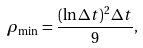<formula> <loc_0><loc_0><loc_500><loc_500>\rho _ { \min } = \frac { ( \ln \Delta t ) ^ { 2 } \Delta t } { 9 } ,</formula> 